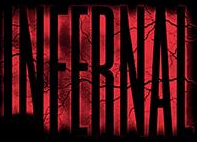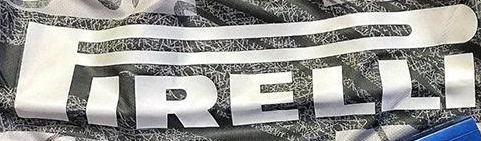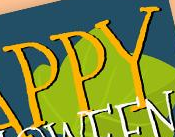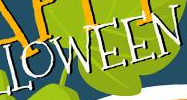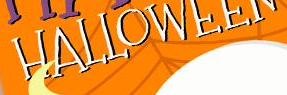What words are shown in these images in order, separated by a semicolon? INFERNAL; PIRELLI; PPY; LOWEEN; HALLOWEEN 